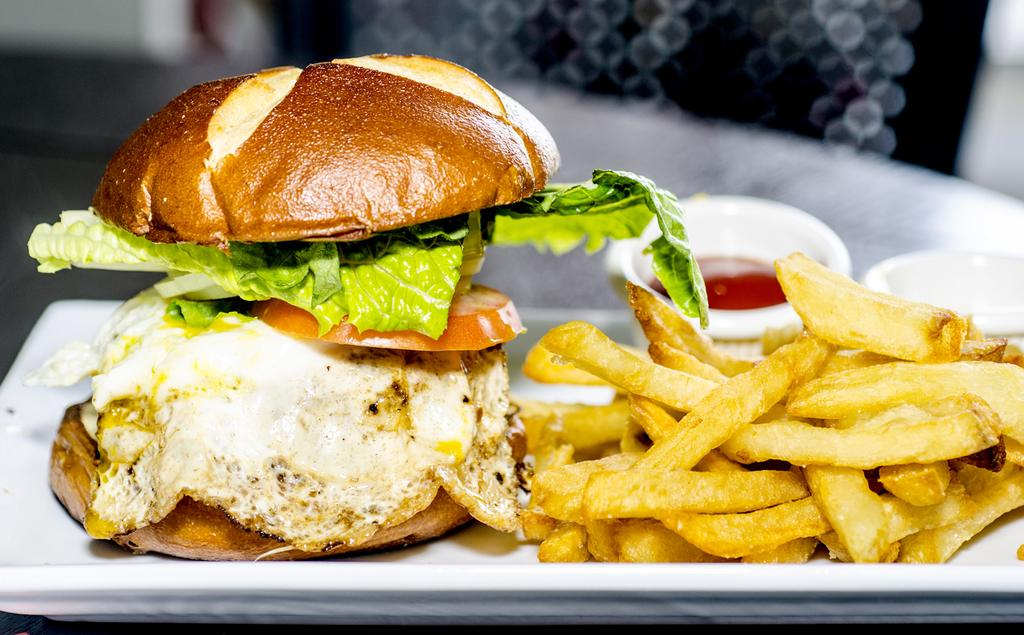What is on the plate in the image? There are food items on the plate in the image. What else can be seen behind the food items? A: There are bowls with sauce behind the food items. Can you describe the background of the image? The background of the image is blurred. Who is the creator of the balloon that is floating above the food items in the image? There is no balloon present in the image, so it is not possible to determine who the creator might be. 